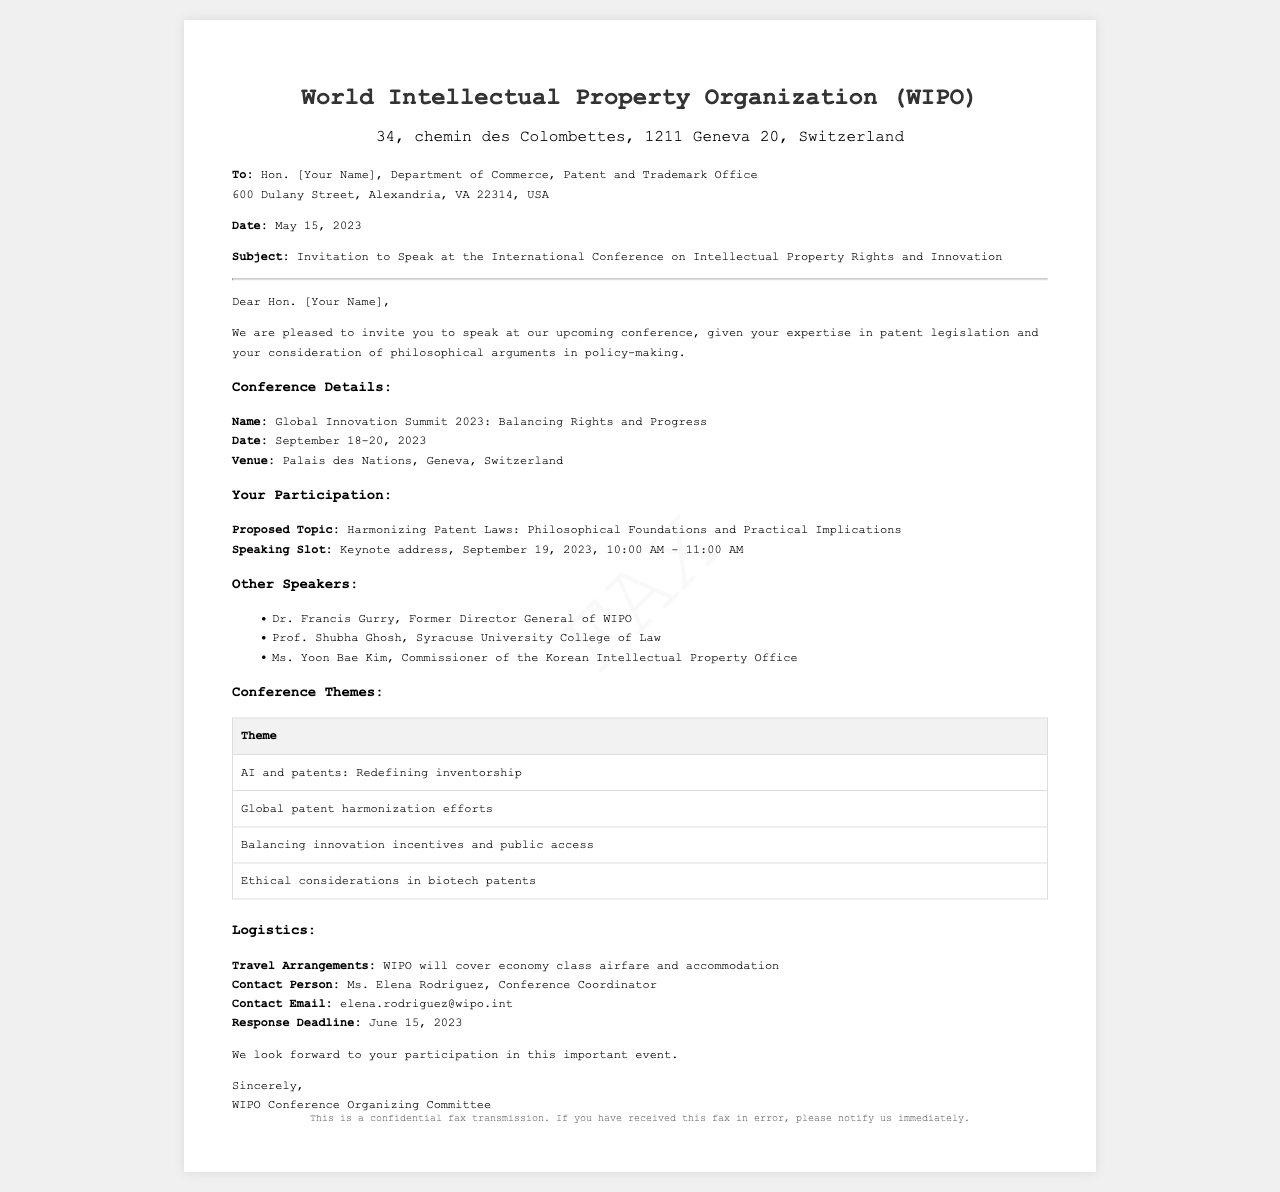What is the name of the conference? The conference is called "Global Innovation Summit 2023: Balancing Rights and Progress."
Answer: Global Innovation Summit 2023: Balancing Rights and Progress Who is the contact person for the conference? The contact person mentioned in the document is Ms. Elena Rodriguez.
Answer: Ms. Elena Rodriguez What is the location of the conference? The venue for the conference is stated as Palais des Nations, Geneva, Switzerland.
Answer: Palais des Nations, Geneva, Switzerland What is the date of the keynote address? The keynote address is scheduled for September 19, 2023.
Answer: September 19, 2023 What is the response deadline for participating in the conference? The document specifies that the response deadline is June 15, 2023.
Answer: June 15, 2023 How long is the keynote address scheduled for? The keynote address is scheduled for one hour, from 10:00 AM to 11:00 AM.
Answer: 10:00 AM - 11:00 AM Who is one of the other speakers mentioned? One of the other speakers listed is Dr. Francis Gurry.
Answer: Dr. Francis Gurry What type of fare will WIPO cover for travel? WIPO will cover economy class airfare as mentioned in the logistics section.
Answer: economy class airfare What is one of the conference themes? One of the themes listed is "AI and patents: Redefining inventorship."
Answer: AI and patents: Redefining inventorship 